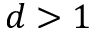Convert formula to latex. <formula><loc_0><loc_0><loc_500><loc_500>d > 1</formula> 